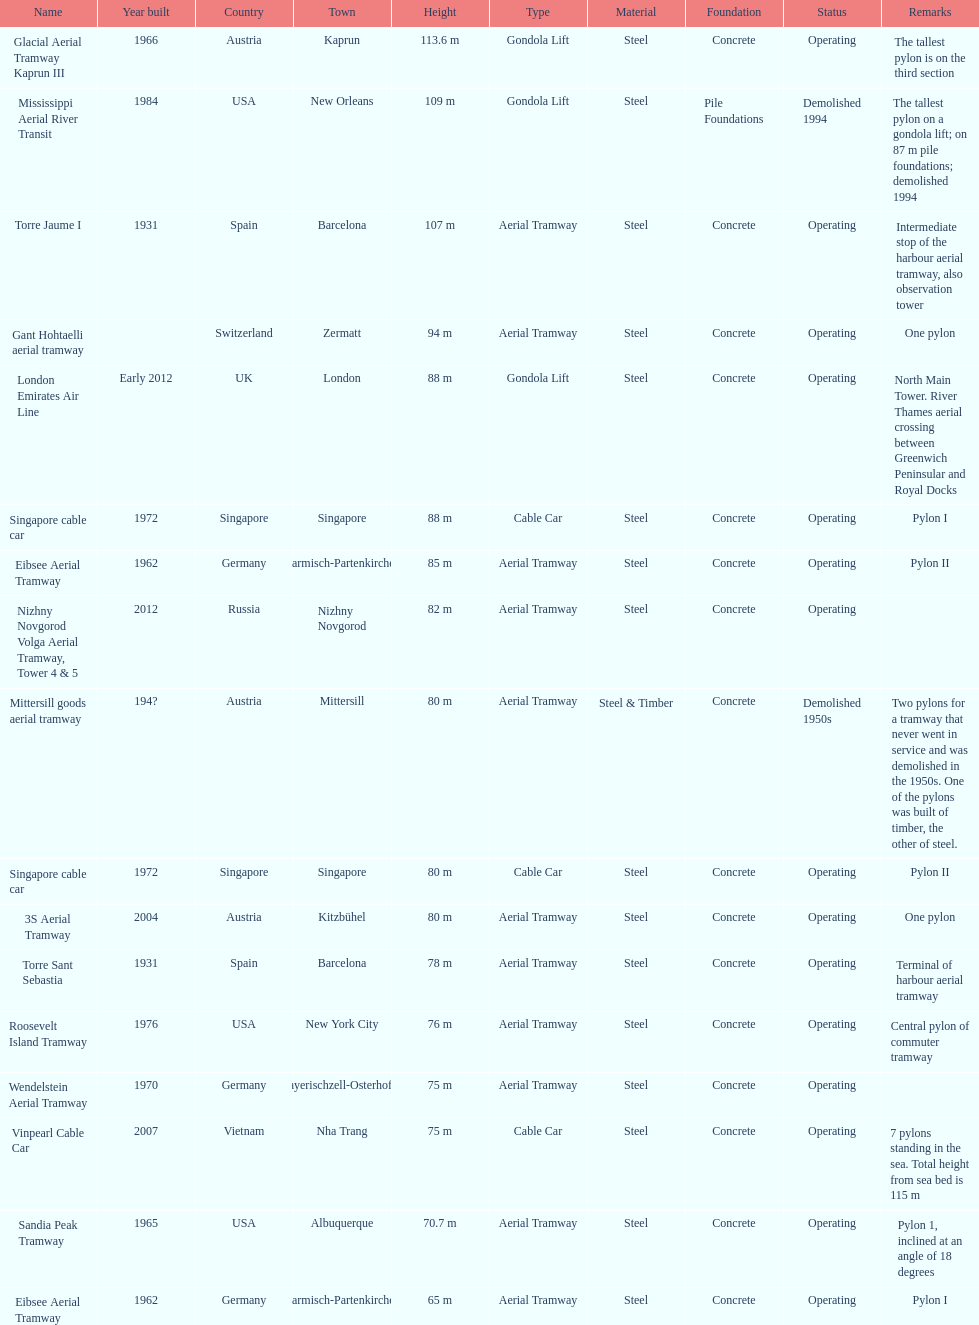What is the total number of pylons listed? 17. 